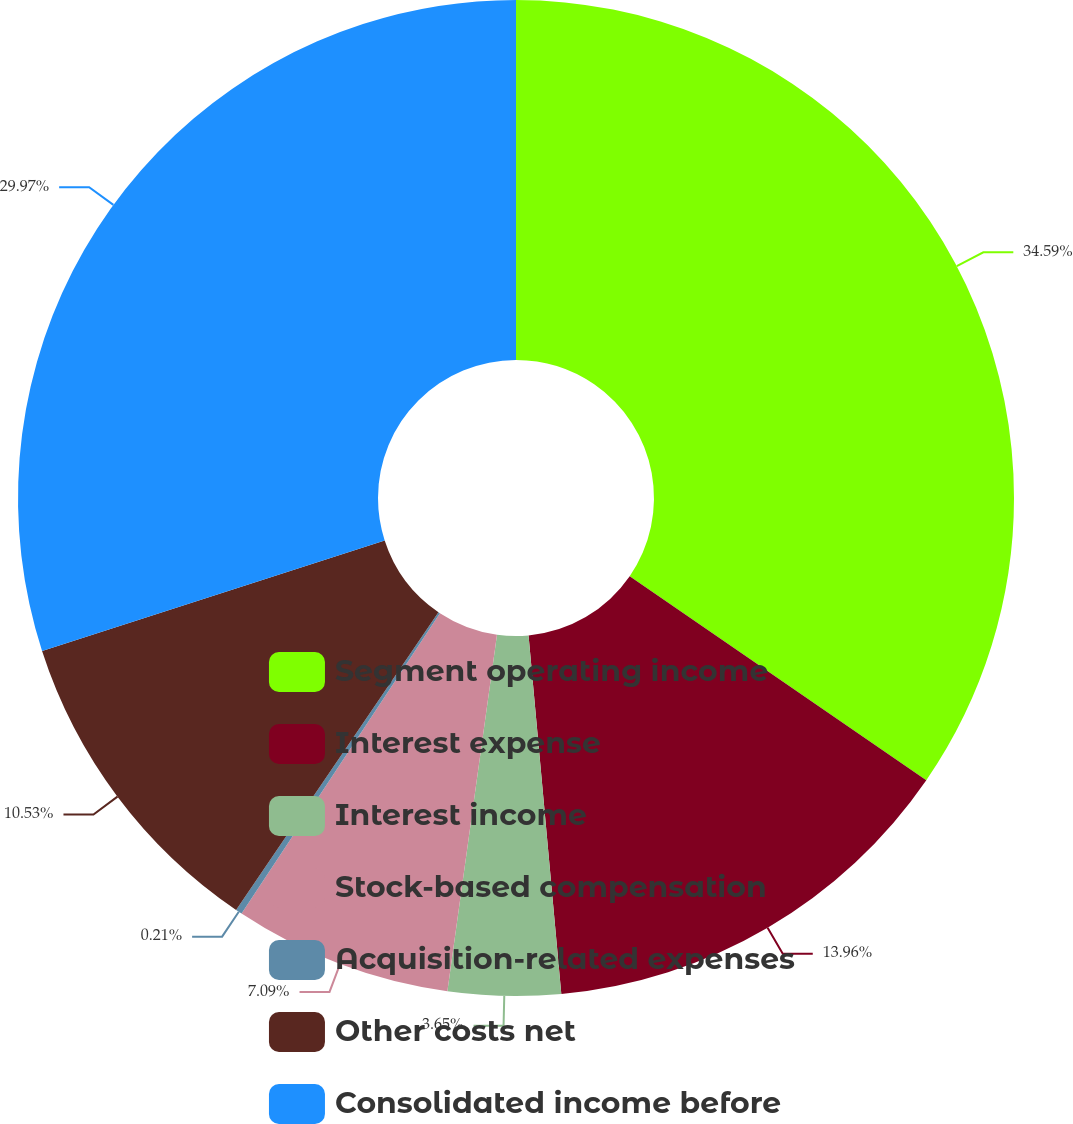<chart> <loc_0><loc_0><loc_500><loc_500><pie_chart><fcel>Segment operating income<fcel>Interest expense<fcel>Interest income<fcel>Stock-based compensation<fcel>Acquisition-related expenses<fcel>Other costs net<fcel>Consolidated income before<nl><fcel>34.59%<fcel>13.96%<fcel>3.65%<fcel>7.09%<fcel>0.21%<fcel>10.53%<fcel>29.97%<nl></chart> 